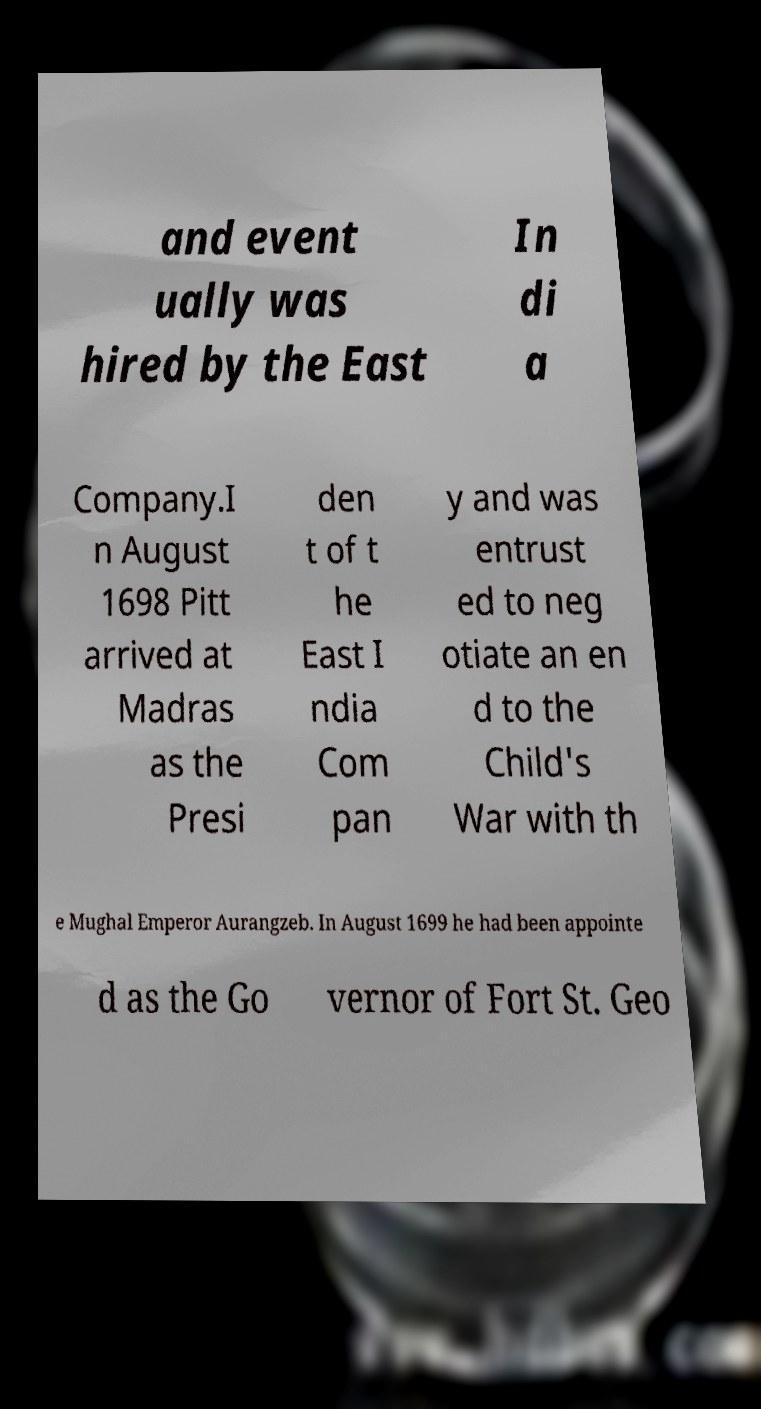Please identify and transcribe the text found in this image. and event ually was hired by the East In di a Company.I n August 1698 Pitt arrived at Madras as the Presi den t of t he East I ndia Com pan y and was entrust ed to neg otiate an en d to the Child's War with th e Mughal Emperor Aurangzeb. In August 1699 he had been appointe d as the Go vernor of Fort St. Geo 